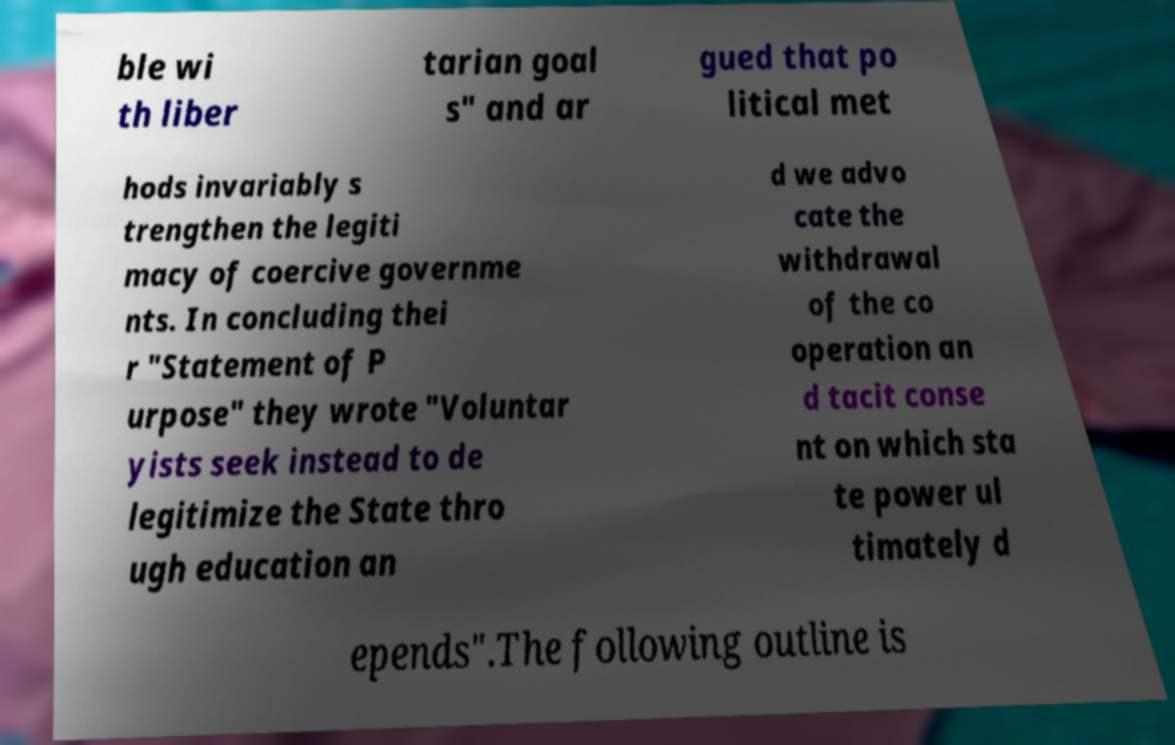I need the written content from this picture converted into text. Can you do that? ble wi th liber tarian goal s" and ar gued that po litical met hods invariably s trengthen the legiti macy of coercive governme nts. In concluding thei r "Statement of P urpose" they wrote "Voluntar yists seek instead to de legitimize the State thro ugh education an d we advo cate the withdrawal of the co operation an d tacit conse nt on which sta te power ul timately d epends".The following outline is 